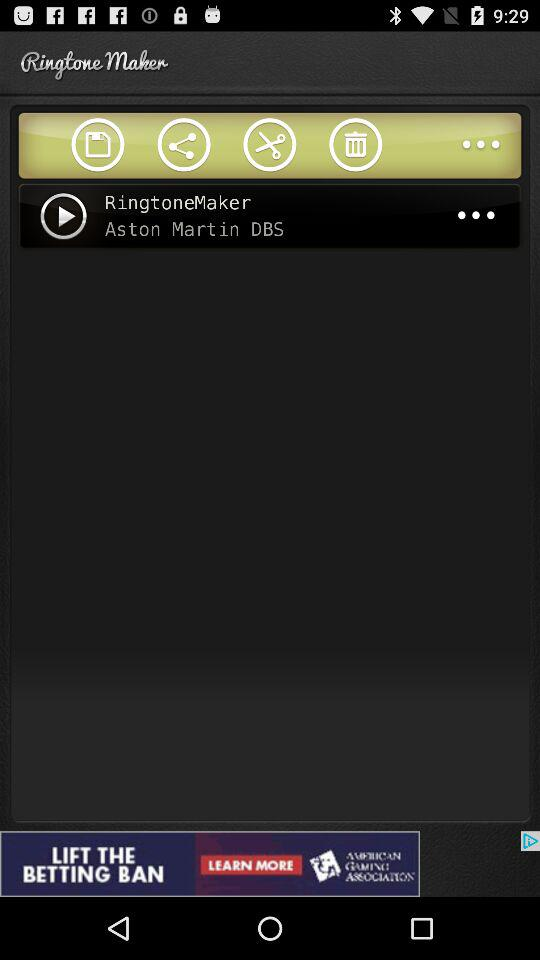How long is "RingtoneMaker"?
When the provided information is insufficient, respond with <no answer>. <no answer> 